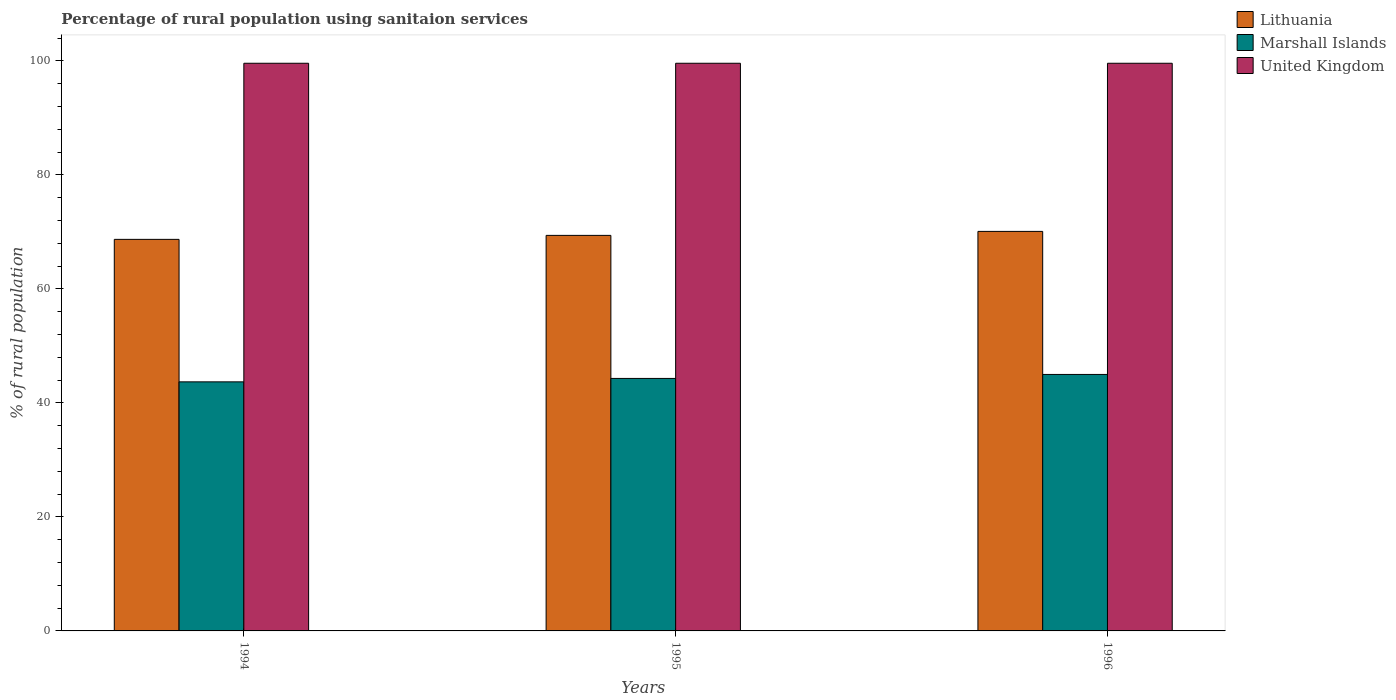How many different coloured bars are there?
Your answer should be compact. 3. Are the number of bars per tick equal to the number of legend labels?
Keep it short and to the point. Yes. How many bars are there on the 1st tick from the right?
Your response must be concise. 3. What is the label of the 3rd group of bars from the left?
Offer a very short reply. 1996. In how many cases, is the number of bars for a given year not equal to the number of legend labels?
Your answer should be compact. 0. What is the percentage of rural population using sanitaion services in United Kingdom in 1994?
Provide a succinct answer. 99.6. Across all years, what is the maximum percentage of rural population using sanitaion services in Marshall Islands?
Ensure brevity in your answer.  45. Across all years, what is the minimum percentage of rural population using sanitaion services in United Kingdom?
Your answer should be compact. 99.6. In which year was the percentage of rural population using sanitaion services in Marshall Islands maximum?
Provide a succinct answer. 1996. What is the total percentage of rural population using sanitaion services in United Kingdom in the graph?
Give a very brief answer. 298.8. What is the difference between the percentage of rural population using sanitaion services in Lithuania in 1994 and that in 1995?
Your answer should be very brief. -0.7. What is the difference between the percentage of rural population using sanitaion services in United Kingdom in 1996 and the percentage of rural population using sanitaion services in Lithuania in 1995?
Provide a short and direct response. 30.2. What is the average percentage of rural population using sanitaion services in Lithuania per year?
Give a very brief answer. 69.4. In the year 1996, what is the difference between the percentage of rural population using sanitaion services in Marshall Islands and percentage of rural population using sanitaion services in Lithuania?
Provide a succinct answer. -25.1. What is the difference between the highest and the second highest percentage of rural population using sanitaion services in Marshall Islands?
Make the answer very short. 0.7. What is the difference between the highest and the lowest percentage of rural population using sanitaion services in Marshall Islands?
Your response must be concise. 1.3. In how many years, is the percentage of rural population using sanitaion services in United Kingdom greater than the average percentage of rural population using sanitaion services in United Kingdom taken over all years?
Offer a very short reply. 3. Is the sum of the percentage of rural population using sanitaion services in United Kingdom in 1995 and 1996 greater than the maximum percentage of rural population using sanitaion services in Marshall Islands across all years?
Offer a terse response. Yes. What does the 2nd bar from the left in 1994 represents?
Keep it short and to the point. Marshall Islands. What does the 1st bar from the right in 1996 represents?
Your answer should be compact. United Kingdom. Is it the case that in every year, the sum of the percentage of rural population using sanitaion services in Lithuania and percentage of rural population using sanitaion services in United Kingdom is greater than the percentage of rural population using sanitaion services in Marshall Islands?
Offer a very short reply. Yes. How many bars are there?
Give a very brief answer. 9. What is the difference between two consecutive major ticks on the Y-axis?
Provide a short and direct response. 20. Where does the legend appear in the graph?
Ensure brevity in your answer.  Top right. What is the title of the graph?
Provide a short and direct response. Percentage of rural population using sanitaion services. What is the label or title of the Y-axis?
Ensure brevity in your answer.  % of rural population. What is the % of rural population in Lithuania in 1994?
Your response must be concise. 68.7. What is the % of rural population in Marshall Islands in 1994?
Give a very brief answer. 43.7. What is the % of rural population of United Kingdom in 1994?
Your answer should be compact. 99.6. What is the % of rural population of Lithuania in 1995?
Make the answer very short. 69.4. What is the % of rural population of Marshall Islands in 1995?
Make the answer very short. 44.3. What is the % of rural population in United Kingdom in 1995?
Your answer should be very brief. 99.6. What is the % of rural population in Lithuania in 1996?
Offer a terse response. 70.1. What is the % of rural population of Marshall Islands in 1996?
Offer a very short reply. 45. What is the % of rural population of United Kingdom in 1996?
Provide a succinct answer. 99.6. Across all years, what is the maximum % of rural population in Lithuania?
Your answer should be very brief. 70.1. Across all years, what is the maximum % of rural population of Marshall Islands?
Your answer should be very brief. 45. Across all years, what is the maximum % of rural population of United Kingdom?
Ensure brevity in your answer.  99.6. Across all years, what is the minimum % of rural population in Lithuania?
Provide a succinct answer. 68.7. Across all years, what is the minimum % of rural population of Marshall Islands?
Your response must be concise. 43.7. Across all years, what is the minimum % of rural population of United Kingdom?
Make the answer very short. 99.6. What is the total % of rural population of Lithuania in the graph?
Make the answer very short. 208.2. What is the total % of rural population of Marshall Islands in the graph?
Offer a terse response. 133. What is the total % of rural population in United Kingdom in the graph?
Offer a terse response. 298.8. What is the difference between the % of rural population in Marshall Islands in 1994 and that in 1995?
Make the answer very short. -0.6. What is the difference between the % of rural population of United Kingdom in 1994 and that in 1996?
Keep it short and to the point. 0. What is the difference between the % of rural population of Lithuania in 1995 and that in 1996?
Provide a succinct answer. -0.7. What is the difference between the % of rural population of Marshall Islands in 1995 and that in 1996?
Keep it short and to the point. -0.7. What is the difference between the % of rural population of United Kingdom in 1995 and that in 1996?
Offer a terse response. 0. What is the difference between the % of rural population of Lithuania in 1994 and the % of rural population of Marshall Islands in 1995?
Your answer should be compact. 24.4. What is the difference between the % of rural population in Lithuania in 1994 and the % of rural population in United Kingdom in 1995?
Offer a very short reply. -30.9. What is the difference between the % of rural population in Marshall Islands in 1994 and the % of rural population in United Kingdom in 1995?
Provide a short and direct response. -55.9. What is the difference between the % of rural population in Lithuania in 1994 and the % of rural population in Marshall Islands in 1996?
Provide a short and direct response. 23.7. What is the difference between the % of rural population of Lithuania in 1994 and the % of rural population of United Kingdom in 1996?
Provide a succinct answer. -30.9. What is the difference between the % of rural population in Marshall Islands in 1994 and the % of rural population in United Kingdom in 1996?
Give a very brief answer. -55.9. What is the difference between the % of rural population of Lithuania in 1995 and the % of rural population of Marshall Islands in 1996?
Ensure brevity in your answer.  24.4. What is the difference between the % of rural population of Lithuania in 1995 and the % of rural population of United Kingdom in 1996?
Make the answer very short. -30.2. What is the difference between the % of rural population of Marshall Islands in 1995 and the % of rural population of United Kingdom in 1996?
Your answer should be very brief. -55.3. What is the average % of rural population of Lithuania per year?
Provide a short and direct response. 69.4. What is the average % of rural population of Marshall Islands per year?
Offer a very short reply. 44.33. What is the average % of rural population in United Kingdom per year?
Provide a short and direct response. 99.6. In the year 1994, what is the difference between the % of rural population in Lithuania and % of rural population in Marshall Islands?
Ensure brevity in your answer.  25. In the year 1994, what is the difference between the % of rural population of Lithuania and % of rural population of United Kingdom?
Offer a very short reply. -30.9. In the year 1994, what is the difference between the % of rural population in Marshall Islands and % of rural population in United Kingdom?
Make the answer very short. -55.9. In the year 1995, what is the difference between the % of rural population of Lithuania and % of rural population of Marshall Islands?
Keep it short and to the point. 25.1. In the year 1995, what is the difference between the % of rural population in Lithuania and % of rural population in United Kingdom?
Your response must be concise. -30.2. In the year 1995, what is the difference between the % of rural population of Marshall Islands and % of rural population of United Kingdom?
Give a very brief answer. -55.3. In the year 1996, what is the difference between the % of rural population of Lithuania and % of rural population of Marshall Islands?
Give a very brief answer. 25.1. In the year 1996, what is the difference between the % of rural population of Lithuania and % of rural population of United Kingdom?
Ensure brevity in your answer.  -29.5. In the year 1996, what is the difference between the % of rural population in Marshall Islands and % of rural population in United Kingdom?
Make the answer very short. -54.6. What is the ratio of the % of rural population in Lithuania in 1994 to that in 1995?
Your response must be concise. 0.99. What is the ratio of the % of rural population of Marshall Islands in 1994 to that in 1995?
Your response must be concise. 0.99. What is the ratio of the % of rural population of United Kingdom in 1994 to that in 1995?
Make the answer very short. 1. What is the ratio of the % of rural population of Marshall Islands in 1994 to that in 1996?
Keep it short and to the point. 0.97. What is the ratio of the % of rural population in Marshall Islands in 1995 to that in 1996?
Keep it short and to the point. 0.98. What is the difference between the highest and the second highest % of rural population in Lithuania?
Offer a very short reply. 0.7. 